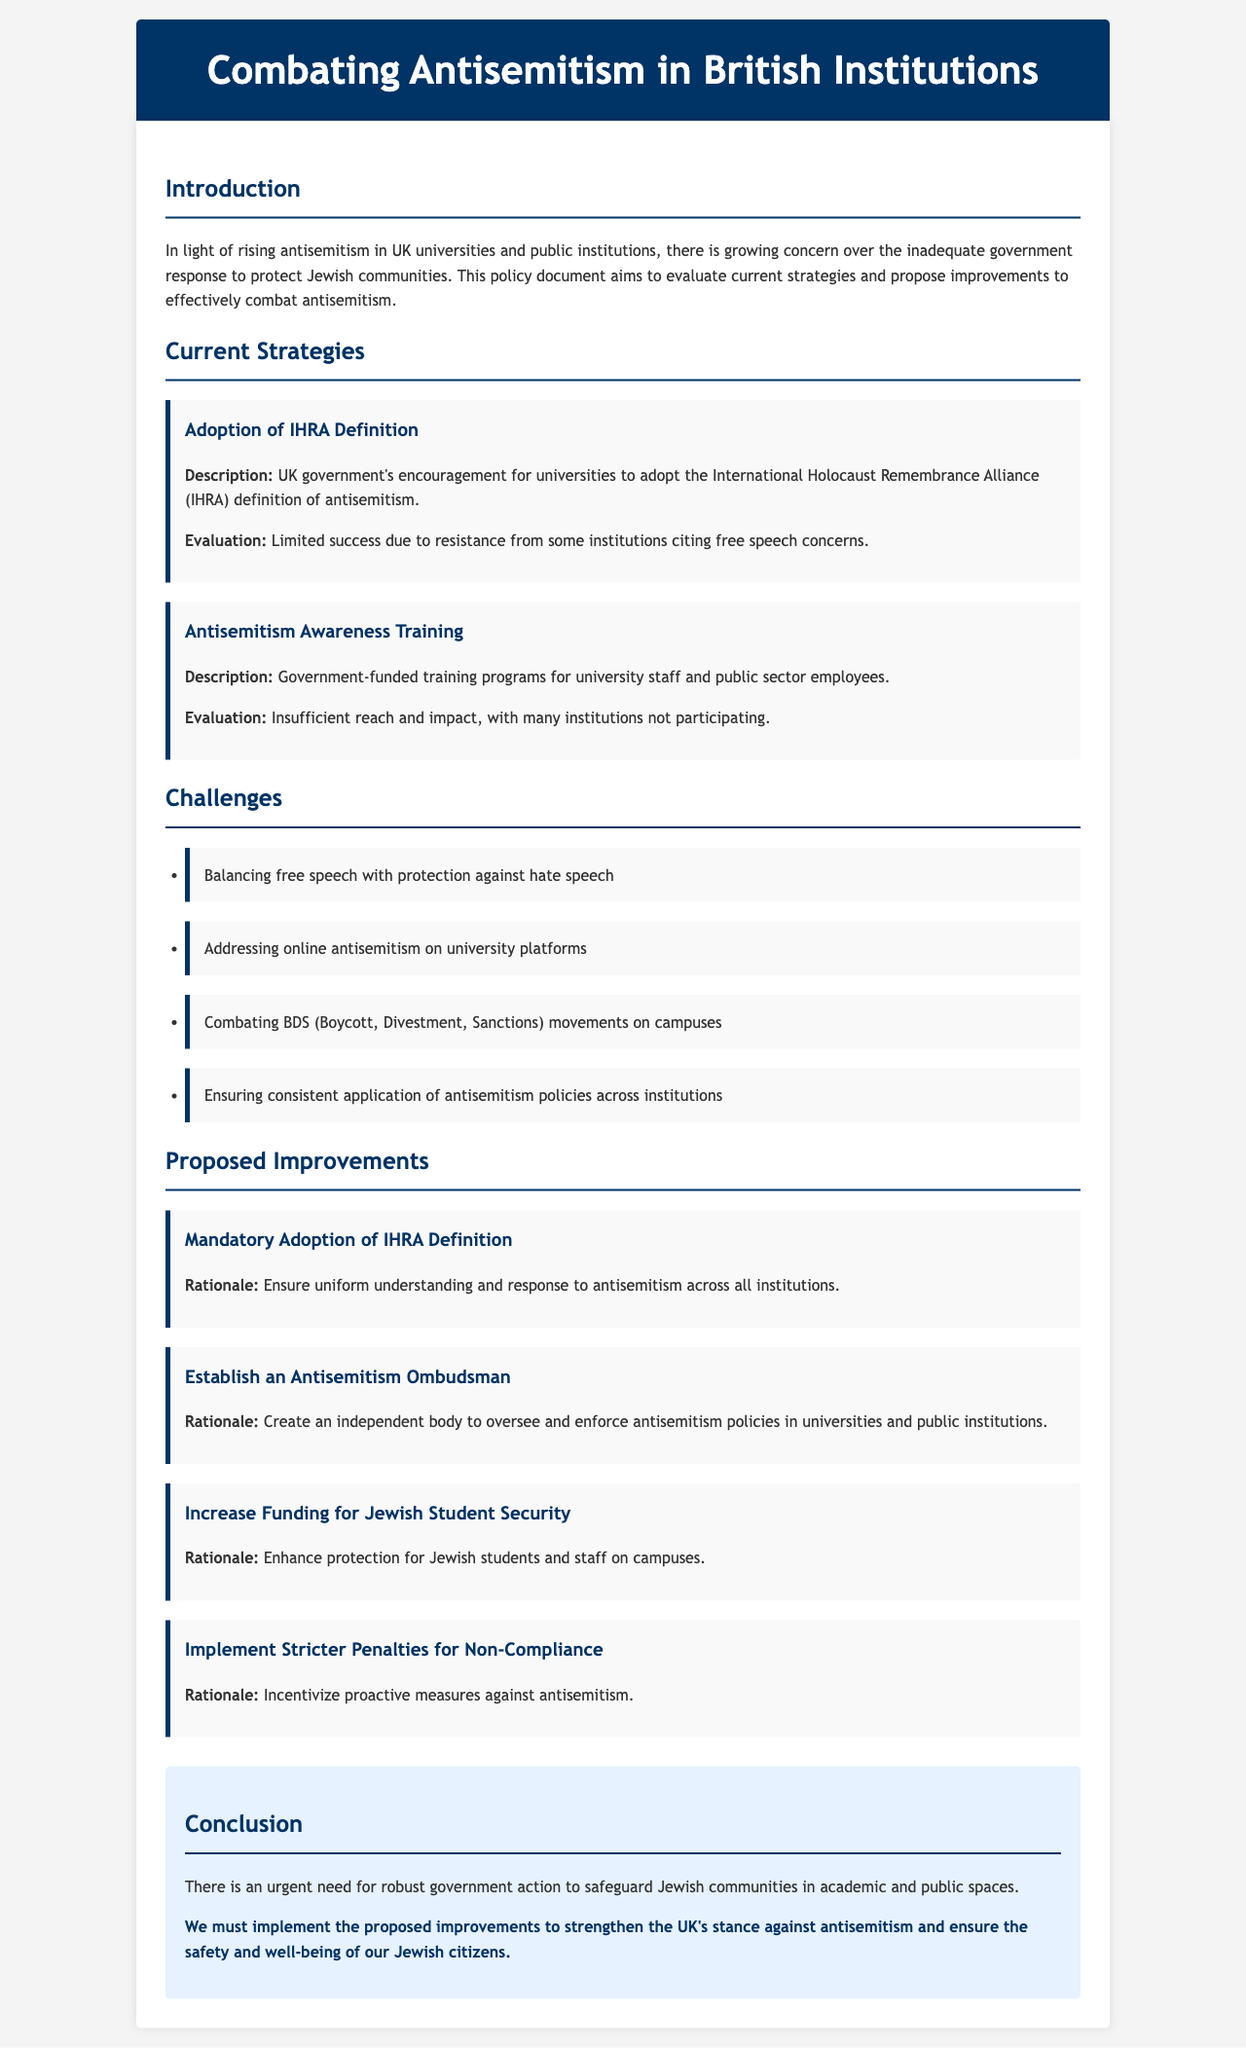What is the title of the document? The title is found in the header section of the document, encapsulating the main theme of the content.
Answer: Combating Antisemitism in British Institutions What is the main concern addressed in the introduction? The introduction outlines a growing concern regarding the government's response to antisemitism, emphasizing the urgency of protecting Jewish communities.
Answer: Inadequate government response What strategy involves the IHRA definition? This strategy discusses the government's encouragement for universities to adopt a specific definition to address antisemitism.
Answer: Adoption of IHRA Definition What challenge is associated with online platforms in universities? This challenge pertains to a specific form of antisemitism that occurs in digital spaces related to university activities.
Answer: Addressing online antisemitism How many proposed improvements are listed in the document? The number of proposed improvements can be counted from the section where they are outlined, detailing specific suggestions for enhancements.
Answer: Four What is the rationale for establishing an Antisemitism Ombudsman? The rationale provided in the document indicates the need for an independent body to ensure proper oversight of antisemitism policies.
Answer: Oversight and enforcement What is required for non-compliance according to the proposed improvements? This point addresses the consequences institutions would face if they do not adhere to implementation measures regarding antisemitism policies.
Answer: Stricter penalties What does the conclusion emphasize as urgent? The conclusion stresses the immediate necessity for intensified government actions to protect Jewish communities in specific environments.
Answer: Robust government action 